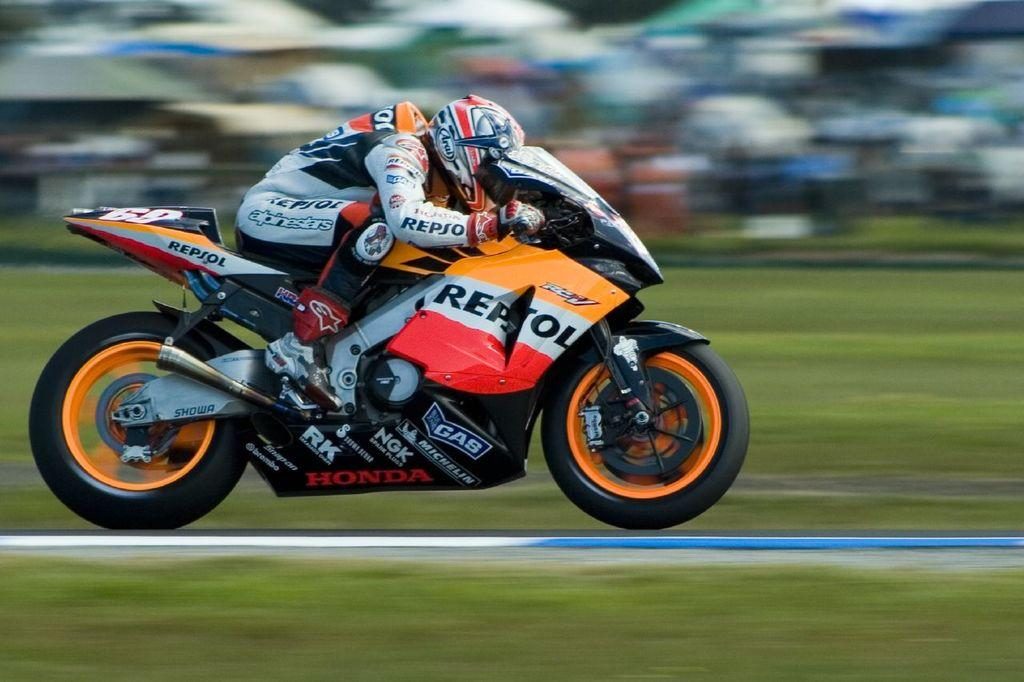What is the main subject of the image? There is a person riding a motorbike in the image. What type of terrain can be seen in the image? There is grass visible in the image. How would you describe the background of the image? The background of the image is blurry. What type of coal is being used by the carpenter in the image? There is no carpenter or coal present in the image. How many clams can be seen in the image? There are no clams present in the image. 